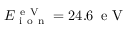<formula> <loc_0><loc_0><loc_500><loc_500>E _ { i o n } ^ { e V } = 2 4 . 6 \, e V</formula> 